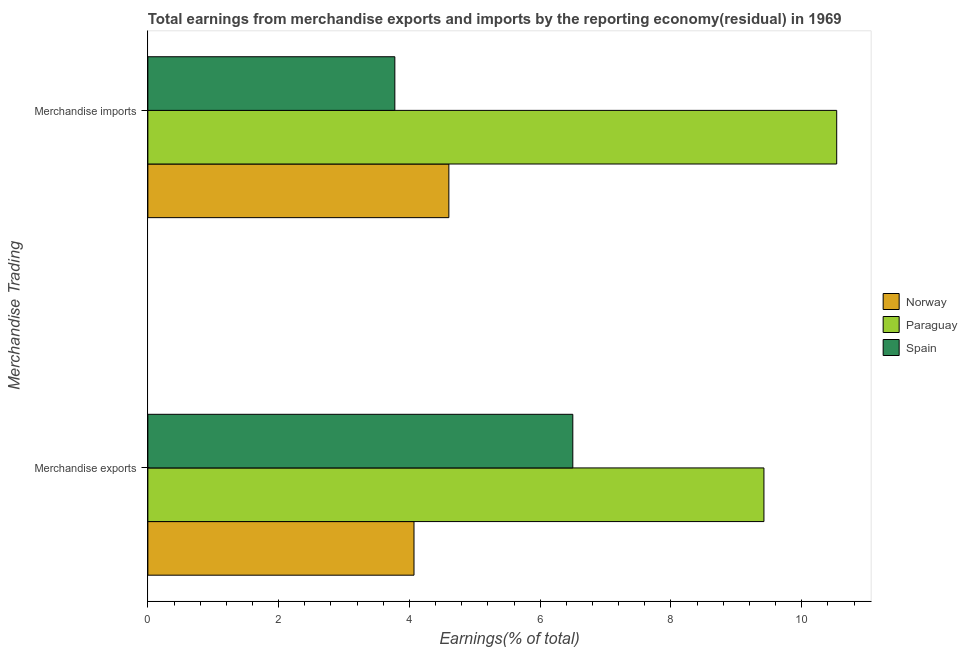How many different coloured bars are there?
Offer a terse response. 3. How many groups of bars are there?
Offer a very short reply. 2. Are the number of bars on each tick of the Y-axis equal?
Your answer should be compact. Yes. How many bars are there on the 1st tick from the top?
Keep it short and to the point. 3. How many bars are there on the 2nd tick from the bottom?
Keep it short and to the point. 3. What is the earnings from merchandise exports in Paraguay?
Provide a succinct answer. 9.42. Across all countries, what is the maximum earnings from merchandise imports?
Make the answer very short. 10.54. Across all countries, what is the minimum earnings from merchandise exports?
Offer a very short reply. 4.07. In which country was the earnings from merchandise imports maximum?
Provide a succinct answer. Paraguay. In which country was the earnings from merchandise exports minimum?
Your answer should be very brief. Norway. What is the total earnings from merchandise exports in the graph?
Give a very brief answer. 19.99. What is the difference between the earnings from merchandise imports in Norway and that in Paraguay?
Your response must be concise. -5.93. What is the difference between the earnings from merchandise exports in Paraguay and the earnings from merchandise imports in Norway?
Make the answer very short. 4.82. What is the average earnings from merchandise imports per country?
Ensure brevity in your answer.  6.31. What is the difference between the earnings from merchandise imports and earnings from merchandise exports in Spain?
Provide a short and direct response. -2.72. What is the ratio of the earnings from merchandise exports in Spain to that in Norway?
Your response must be concise. 1.6. What is the difference between two consecutive major ticks on the X-axis?
Offer a very short reply. 2. Where does the legend appear in the graph?
Ensure brevity in your answer.  Center right. How many legend labels are there?
Give a very brief answer. 3. What is the title of the graph?
Provide a short and direct response. Total earnings from merchandise exports and imports by the reporting economy(residual) in 1969. What is the label or title of the X-axis?
Provide a succinct answer. Earnings(% of total). What is the label or title of the Y-axis?
Ensure brevity in your answer.  Merchandise Trading. What is the Earnings(% of total) of Norway in Merchandise exports?
Provide a short and direct response. 4.07. What is the Earnings(% of total) in Paraguay in Merchandise exports?
Provide a succinct answer. 9.42. What is the Earnings(% of total) of Spain in Merchandise exports?
Provide a short and direct response. 6.5. What is the Earnings(% of total) of Norway in Merchandise imports?
Your answer should be compact. 4.6. What is the Earnings(% of total) of Paraguay in Merchandise imports?
Provide a short and direct response. 10.54. What is the Earnings(% of total) of Spain in Merchandise imports?
Keep it short and to the point. 3.78. Across all Merchandise Trading, what is the maximum Earnings(% of total) in Norway?
Give a very brief answer. 4.6. Across all Merchandise Trading, what is the maximum Earnings(% of total) in Paraguay?
Offer a very short reply. 10.54. Across all Merchandise Trading, what is the maximum Earnings(% of total) in Spain?
Offer a very short reply. 6.5. Across all Merchandise Trading, what is the minimum Earnings(% of total) of Norway?
Provide a short and direct response. 4.07. Across all Merchandise Trading, what is the minimum Earnings(% of total) of Paraguay?
Keep it short and to the point. 9.42. Across all Merchandise Trading, what is the minimum Earnings(% of total) of Spain?
Offer a very short reply. 3.78. What is the total Earnings(% of total) of Norway in the graph?
Give a very brief answer. 8.67. What is the total Earnings(% of total) in Paraguay in the graph?
Offer a very short reply. 19.96. What is the total Earnings(% of total) of Spain in the graph?
Ensure brevity in your answer.  10.28. What is the difference between the Earnings(% of total) in Norway in Merchandise exports and that in Merchandise imports?
Offer a terse response. -0.53. What is the difference between the Earnings(% of total) of Paraguay in Merchandise exports and that in Merchandise imports?
Offer a very short reply. -1.11. What is the difference between the Earnings(% of total) of Spain in Merchandise exports and that in Merchandise imports?
Make the answer very short. 2.72. What is the difference between the Earnings(% of total) in Norway in Merchandise exports and the Earnings(% of total) in Paraguay in Merchandise imports?
Offer a terse response. -6.46. What is the difference between the Earnings(% of total) of Norway in Merchandise exports and the Earnings(% of total) of Spain in Merchandise imports?
Offer a very short reply. 0.29. What is the difference between the Earnings(% of total) in Paraguay in Merchandise exports and the Earnings(% of total) in Spain in Merchandise imports?
Ensure brevity in your answer.  5.64. What is the average Earnings(% of total) in Norway per Merchandise Trading?
Your answer should be very brief. 4.34. What is the average Earnings(% of total) of Paraguay per Merchandise Trading?
Give a very brief answer. 9.98. What is the average Earnings(% of total) of Spain per Merchandise Trading?
Offer a very short reply. 5.14. What is the difference between the Earnings(% of total) of Norway and Earnings(% of total) of Paraguay in Merchandise exports?
Your response must be concise. -5.35. What is the difference between the Earnings(% of total) of Norway and Earnings(% of total) of Spain in Merchandise exports?
Give a very brief answer. -2.43. What is the difference between the Earnings(% of total) of Paraguay and Earnings(% of total) of Spain in Merchandise exports?
Your answer should be compact. 2.92. What is the difference between the Earnings(% of total) in Norway and Earnings(% of total) in Paraguay in Merchandise imports?
Your answer should be compact. -5.93. What is the difference between the Earnings(% of total) of Norway and Earnings(% of total) of Spain in Merchandise imports?
Ensure brevity in your answer.  0.83. What is the difference between the Earnings(% of total) in Paraguay and Earnings(% of total) in Spain in Merchandise imports?
Provide a succinct answer. 6.76. What is the ratio of the Earnings(% of total) in Norway in Merchandise exports to that in Merchandise imports?
Offer a very short reply. 0.88. What is the ratio of the Earnings(% of total) of Paraguay in Merchandise exports to that in Merchandise imports?
Provide a succinct answer. 0.89. What is the ratio of the Earnings(% of total) in Spain in Merchandise exports to that in Merchandise imports?
Offer a terse response. 1.72. What is the difference between the highest and the second highest Earnings(% of total) of Norway?
Your answer should be compact. 0.53. What is the difference between the highest and the second highest Earnings(% of total) in Paraguay?
Offer a terse response. 1.11. What is the difference between the highest and the second highest Earnings(% of total) of Spain?
Your answer should be compact. 2.72. What is the difference between the highest and the lowest Earnings(% of total) of Norway?
Your answer should be compact. 0.53. What is the difference between the highest and the lowest Earnings(% of total) of Paraguay?
Offer a very short reply. 1.11. What is the difference between the highest and the lowest Earnings(% of total) of Spain?
Your answer should be compact. 2.72. 